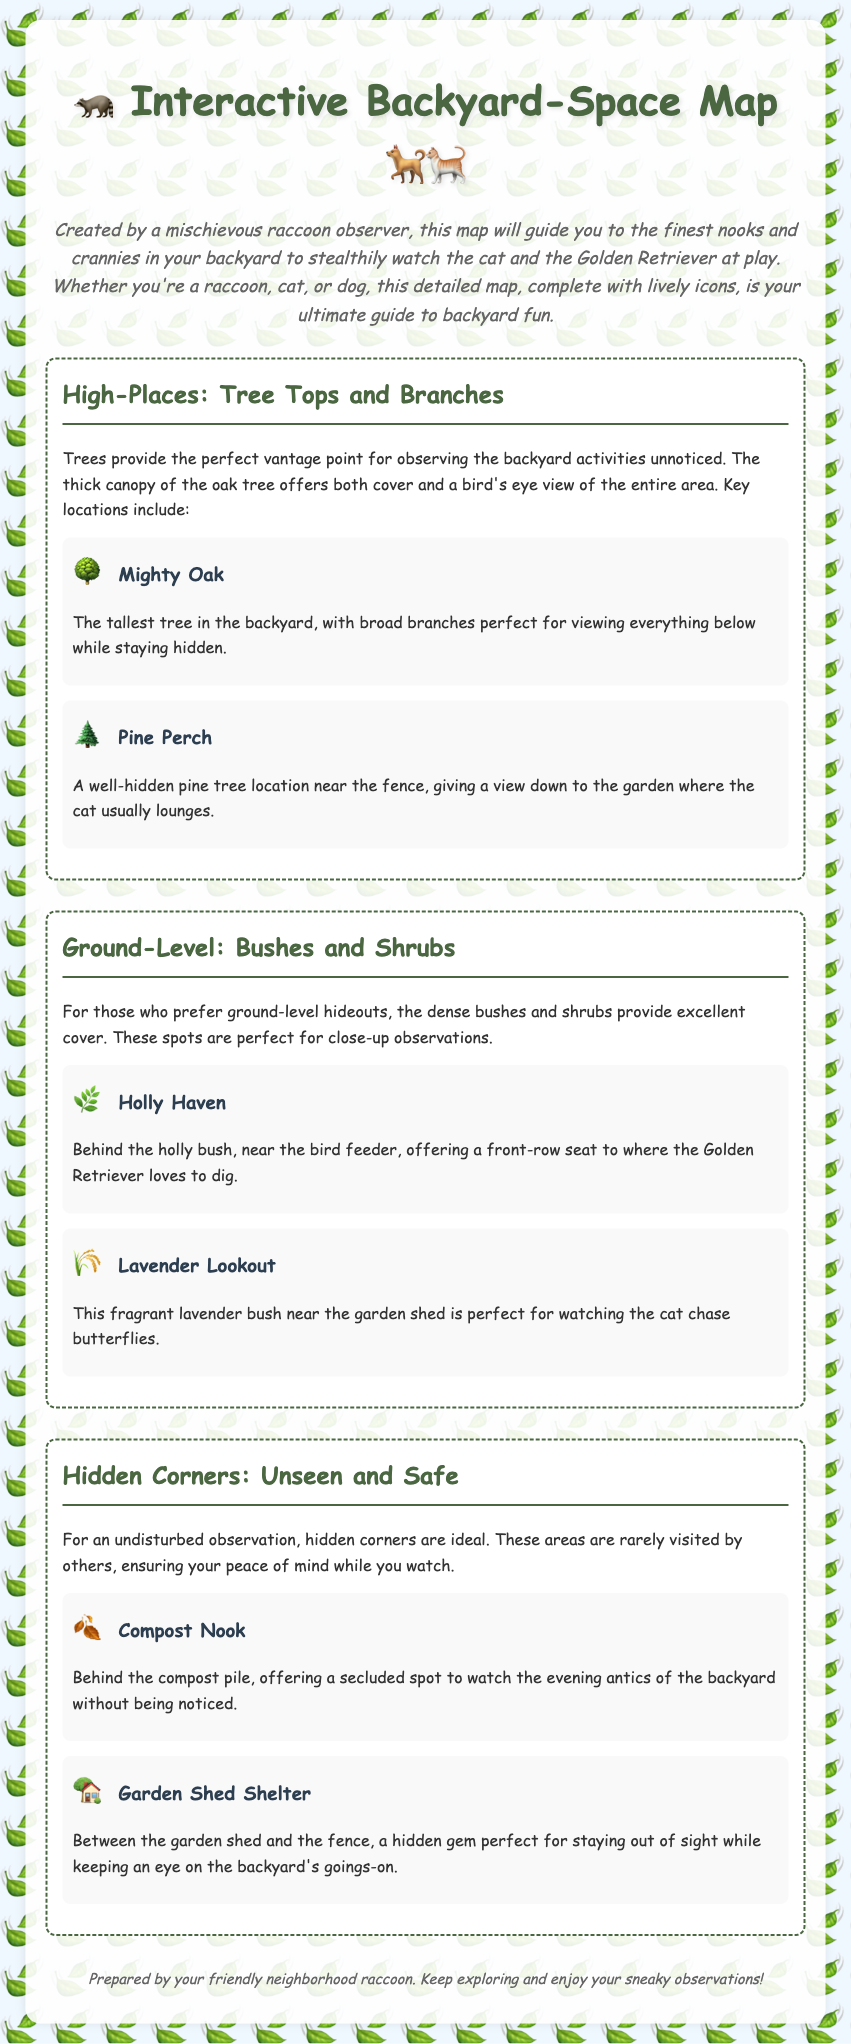what is the title of the document? The title is prominently displayed at the top of the document, indicating its purpose.
Answer: Interactive Backyard-Space Map who created the map? The author is mentioned in the introductory paragraph as the one who prepared the map.
Answer: a mischievous raccoon observer how many high-place locations are mentioned? The section lists two specific locations in the high-places category.
Answer: 2 which tree is described as the tallest? The tallest tree is identified by name in the high-places section.
Answer: Mighty Oak what is the name of the bush near the bird feeder? The document specifies this location in the ground-level section, providing its unique name.
Answer: Holly Haven where is the hidden garden shed shelter located? This information is provided in the hidden corners section, giving the precise spot.
Answer: between the garden shed and the fence what type of icons are used throughout the map? The document describes the nature of the icons that illustrate the various areas.
Answer: lively icons of raccoons, cats, and dogs which observation spot is ideal for watching the Golden Retriever dig? The location specific for observing the Golden Retriever is highlighted in the ground-level section.
Answer: Holly Haven 